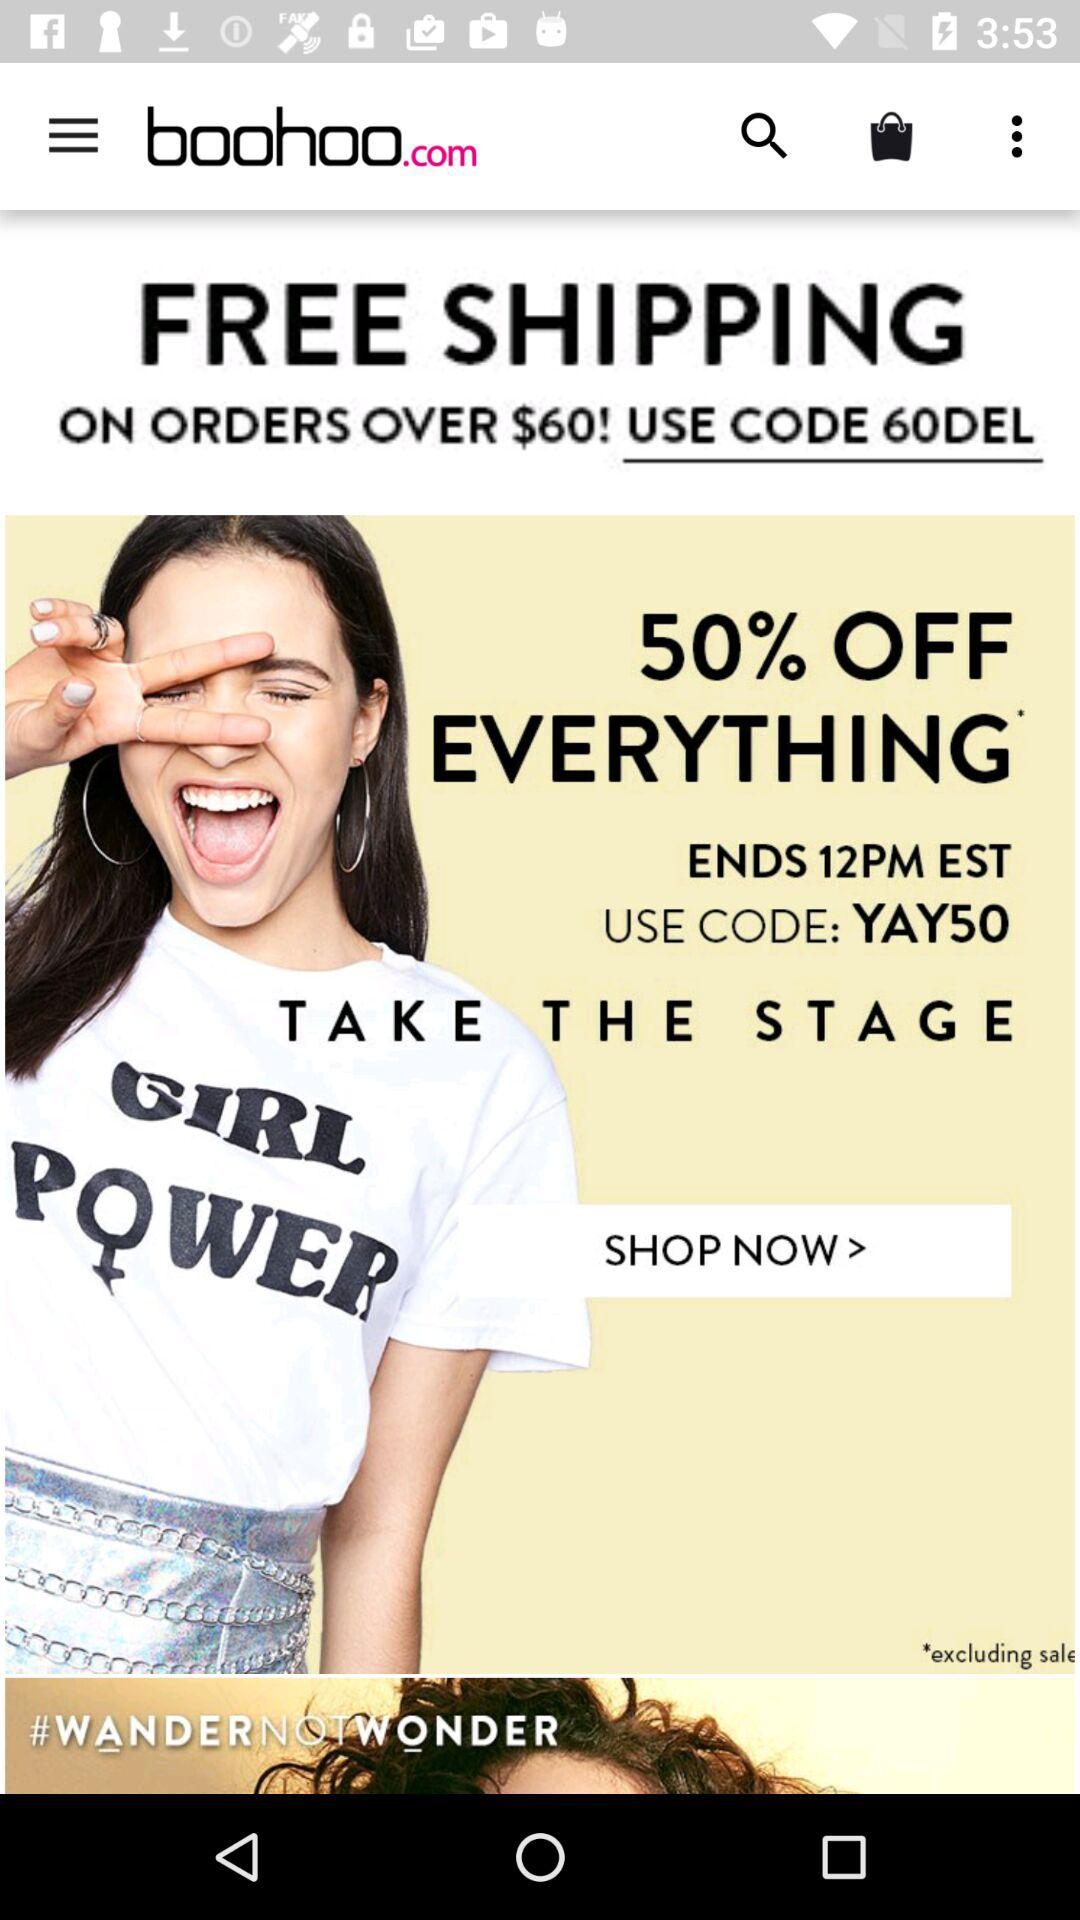When will the offer end? The offer will end at 12 p.m. EST. 